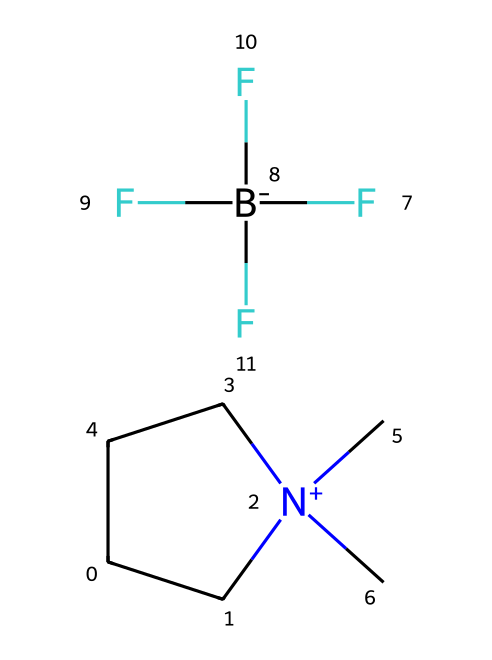How many carbon atoms are in the molecule? The SMILES representation shows "C" and "CC" which indicates the presence of multiple carbon atoms. By counting, there are four carbon atoms in total.
Answer: four What is the charge of the nitrogen atom in this ionic liquid? The nitrogen in the SMILES representation is indicated by "[N+]", which signifies a positive charge on the nitrogen atom.
Answer: positive How many fluorine atoms are present in the molecule? The notation "F" appears three times in the SMILES, indicating that there are three fluorine atoms in total in the chemical structure.
Answer: three What type of chemical compound is represented by this SMILES? The presence of a quaternary ammonium ion ("[N+]") along with a counteranion ("F[B-](F)(F)F") defines this compound as an ionic liquid, commonly used in electrochemical applications.
Answer: ionic liquid What is the significance of the fluorinated counteranion in this ionic liquid? The fluorinated counteranion significantly contributes to the ionic liquid's conductivity and electrochemical stability due to its highly electronegative fluorine atoms.
Answer: conductivity What functional group is indicated by the presence of the nitrogen atom? The nitrogen atom's positive charge and its connectivity suggest that it is part of a quaternary ammonium group, a common functional group in ionic liquids.
Answer: quaternary ammonium What effect does the structure of this ionic liquid have on its applications in military batteries? The stable ionic structure and high thermal stability rendered by the fluorine-containing counteranion make this ionic liquid suitable for high-performance military battery applications, offering improved safety and efficiency.
Answer: high-performance 